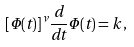Convert formula to latex. <formula><loc_0><loc_0><loc_500><loc_500>[ \Phi ( t ) ] ^ { \nu } \frac { d } { d t } \Phi ( t ) = k \, ,</formula> 